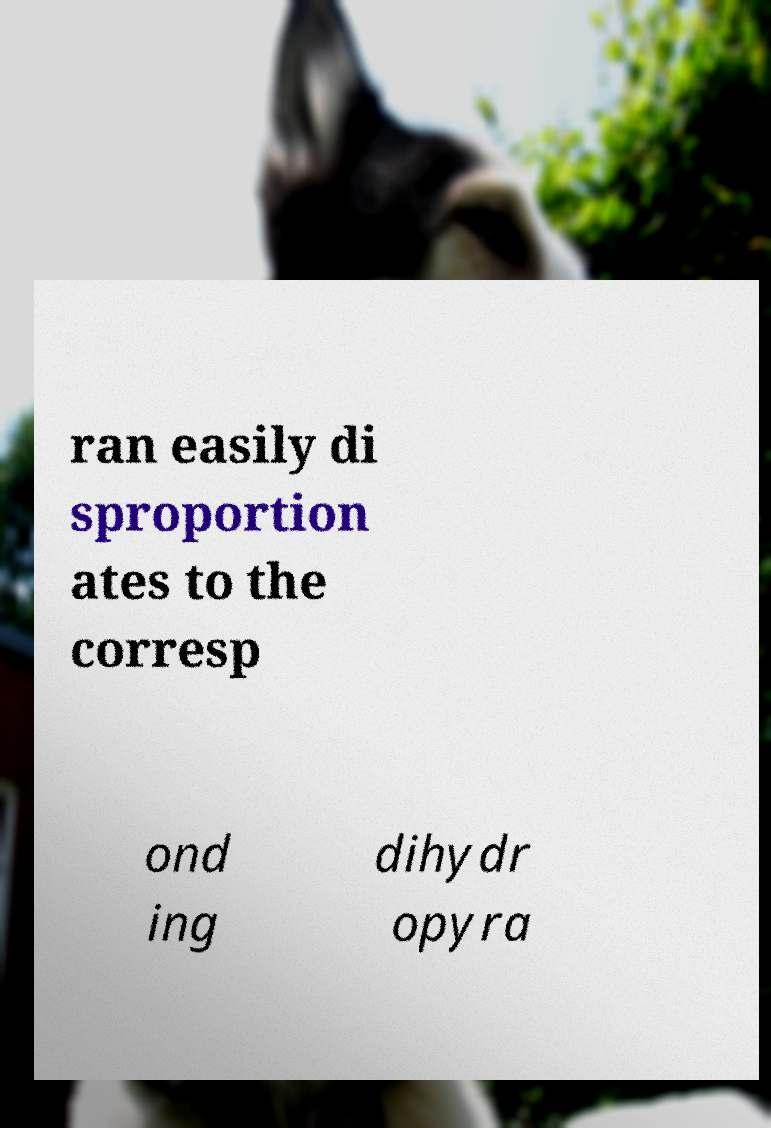For documentation purposes, I need the text within this image transcribed. Could you provide that? ran easily di sproportion ates to the corresp ond ing dihydr opyra 